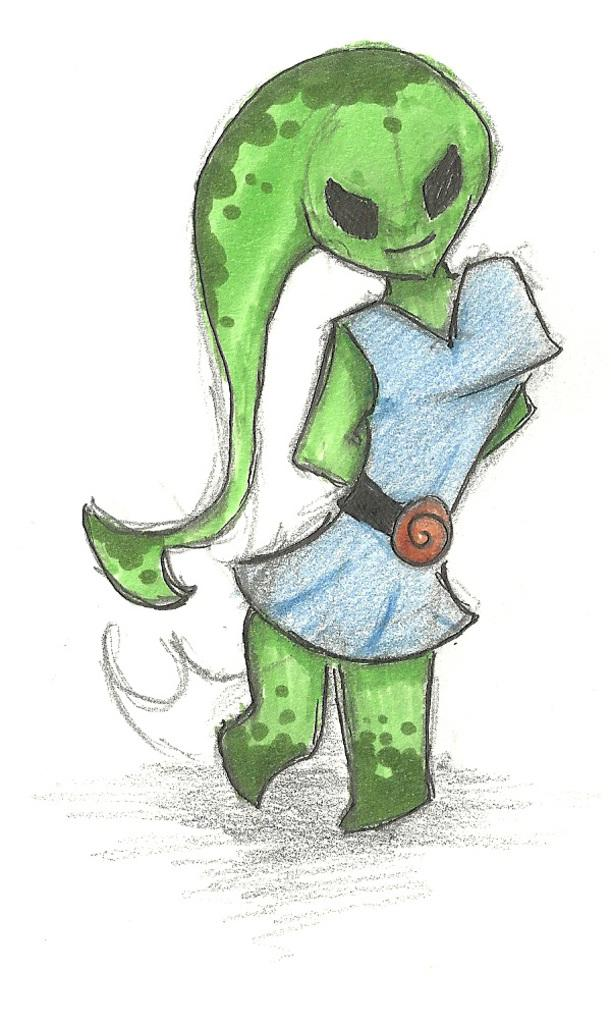What is the main subject of the image? There is a drawing in the center of the image. Can you describe the drawing? The drawing contains different colors and depicts a person. What type of holiday is being celebrated in the drawing? There is no indication of a holiday being celebrated in the drawing; it simply depicts a person. 